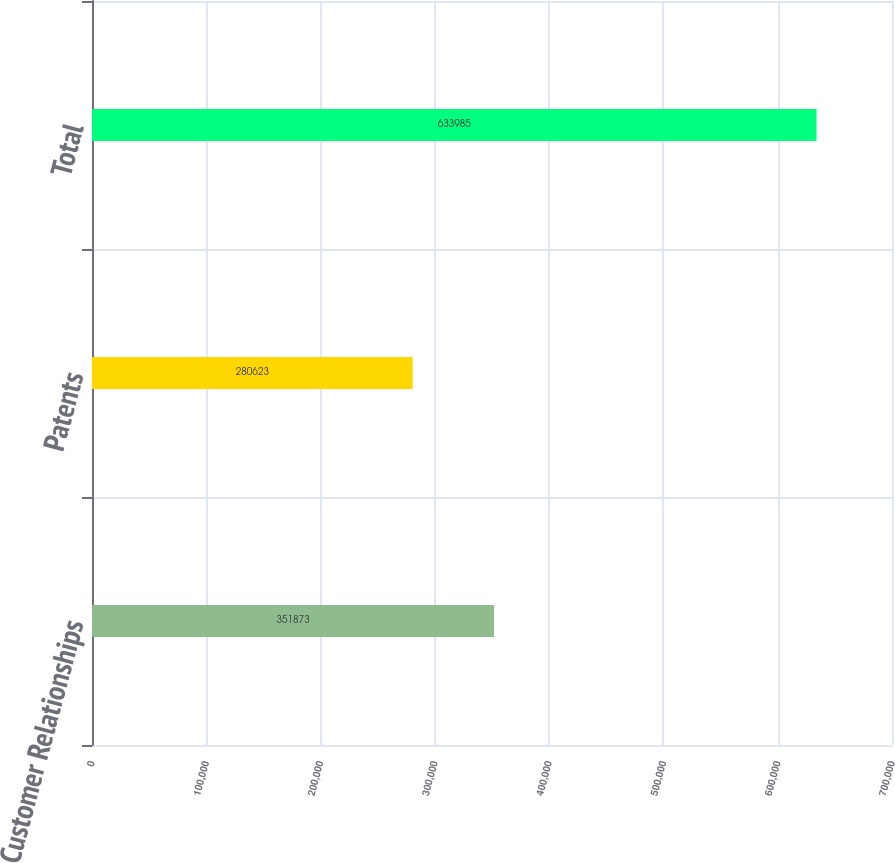Convert chart. <chart><loc_0><loc_0><loc_500><loc_500><bar_chart><fcel>Customer Relationships<fcel>Patents<fcel>Total<nl><fcel>351873<fcel>280623<fcel>633985<nl></chart> 